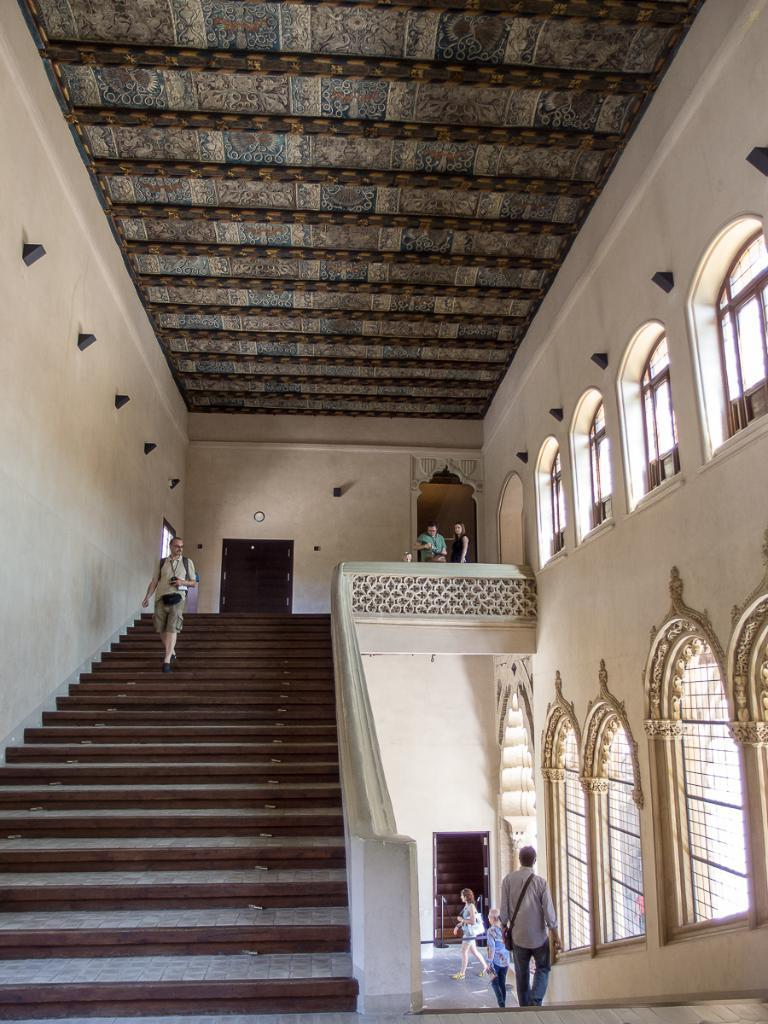What type of location is depicted in the image? The image shows an inside view of a building. What are the people in the image doing? There are people walking down the stairs in the image. What feature can be seen beside the stairs? There are glass windows beside the stairs in the image. How many stars can be seen on the mask worn by the person walking down the stairs in the image? There is no mask or star present in the image. 